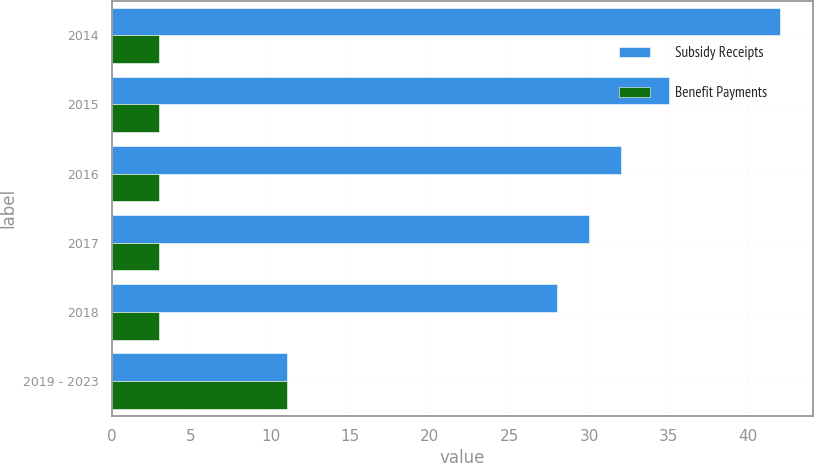Convert chart to OTSL. <chart><loc_0><loc_0><loc_500><loc_500><stacked_bar_chart><ecel><fcel>2014<fcel>2015<fcel>2016<fcel>2017<fcel>2018<fcel>2019 - 2023<nl><fcel>Subsidy Receipts<fcel>42<fcel>35<fcel>32<fcel>30<fcel>28<fcel>11<nl><fcel>Benefit Payments<fcel>3<fcel>3<fcel>3<fcel>3<fcel>3<fcel>11<nl></chart> 